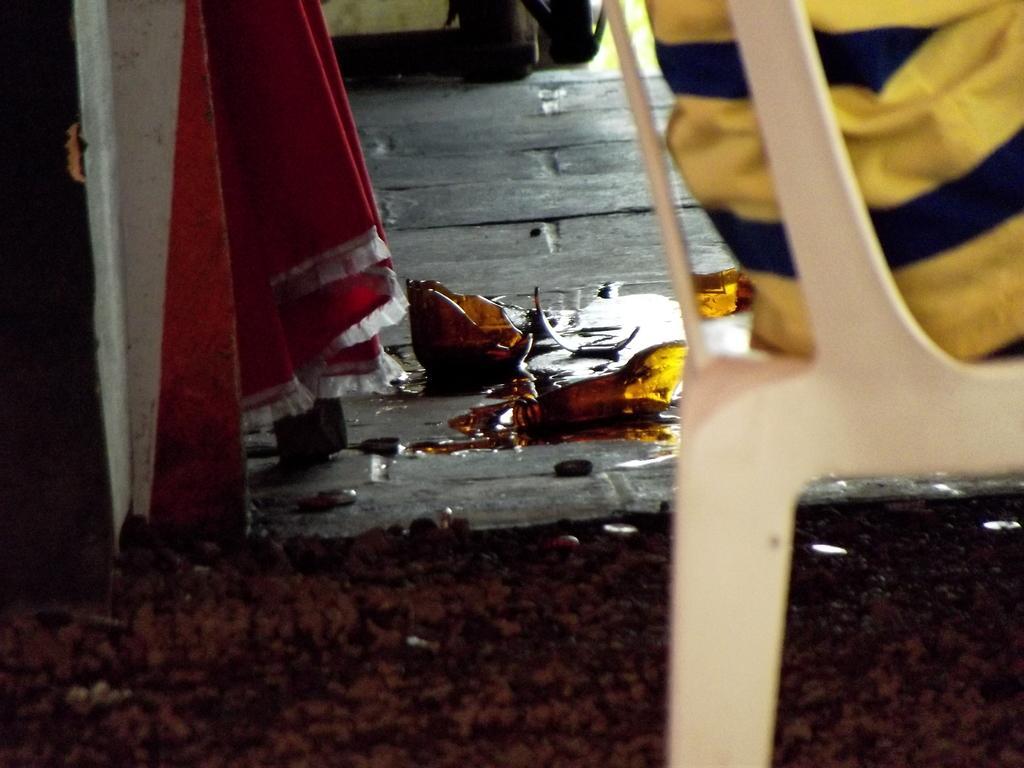Can you describe this image briefly? In this image I can see a broken glass with some liquid in the center of the image. At the bottom of the image I can see a carpet. On the left side of the image I can see a table with wheels and a red color cloth. On the right hand side of the image I can see a person sitting in a plastic chair. 